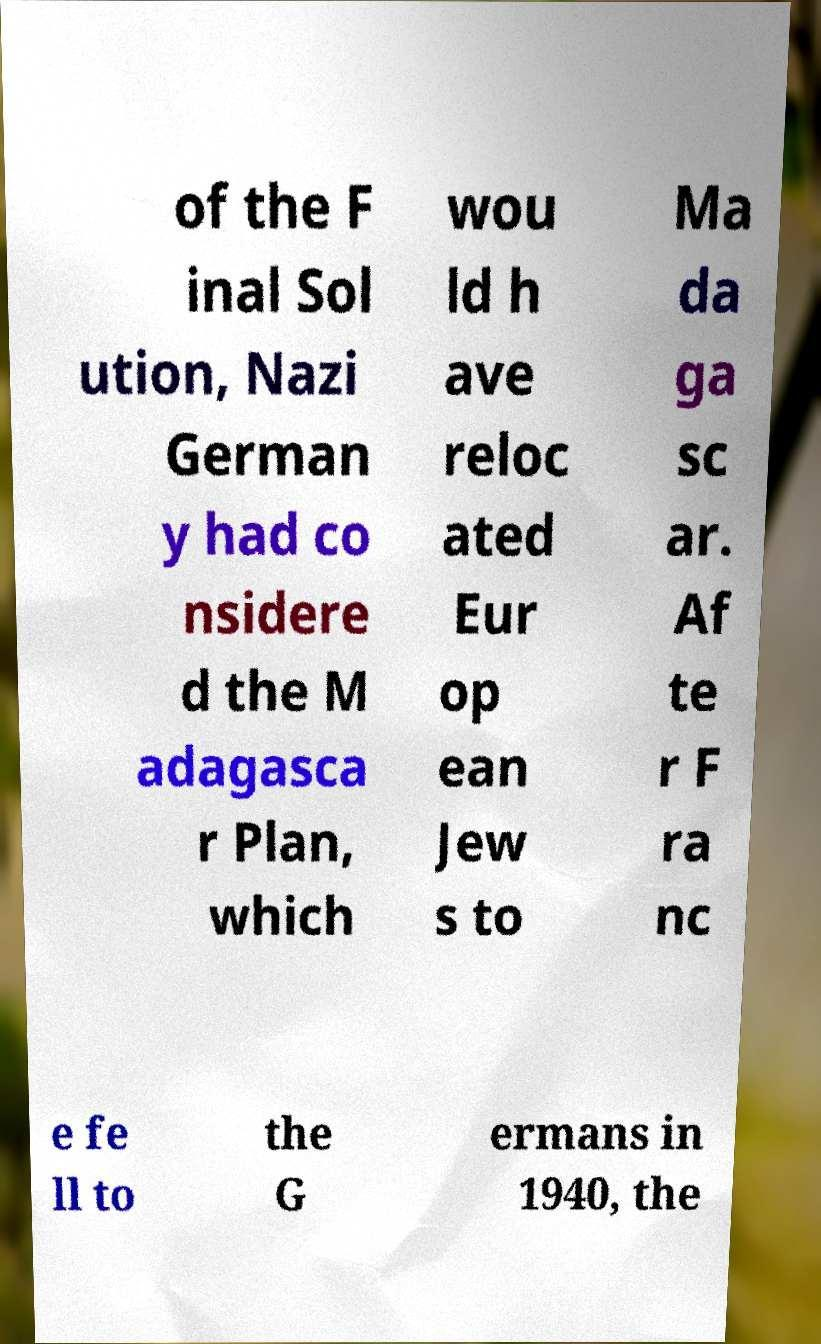There's text embedded in this image that I need extracted. Can you transcribe it verbatim? of the F inal Sol ution, Nazi German y had co nsidere d the M adagasca r Plan, which wou ld h ave reloc ated Eur op ean Jew s to Ma da ga sc ar. Af te r F ra nc e fe ll to the G ermans in 1940, the 